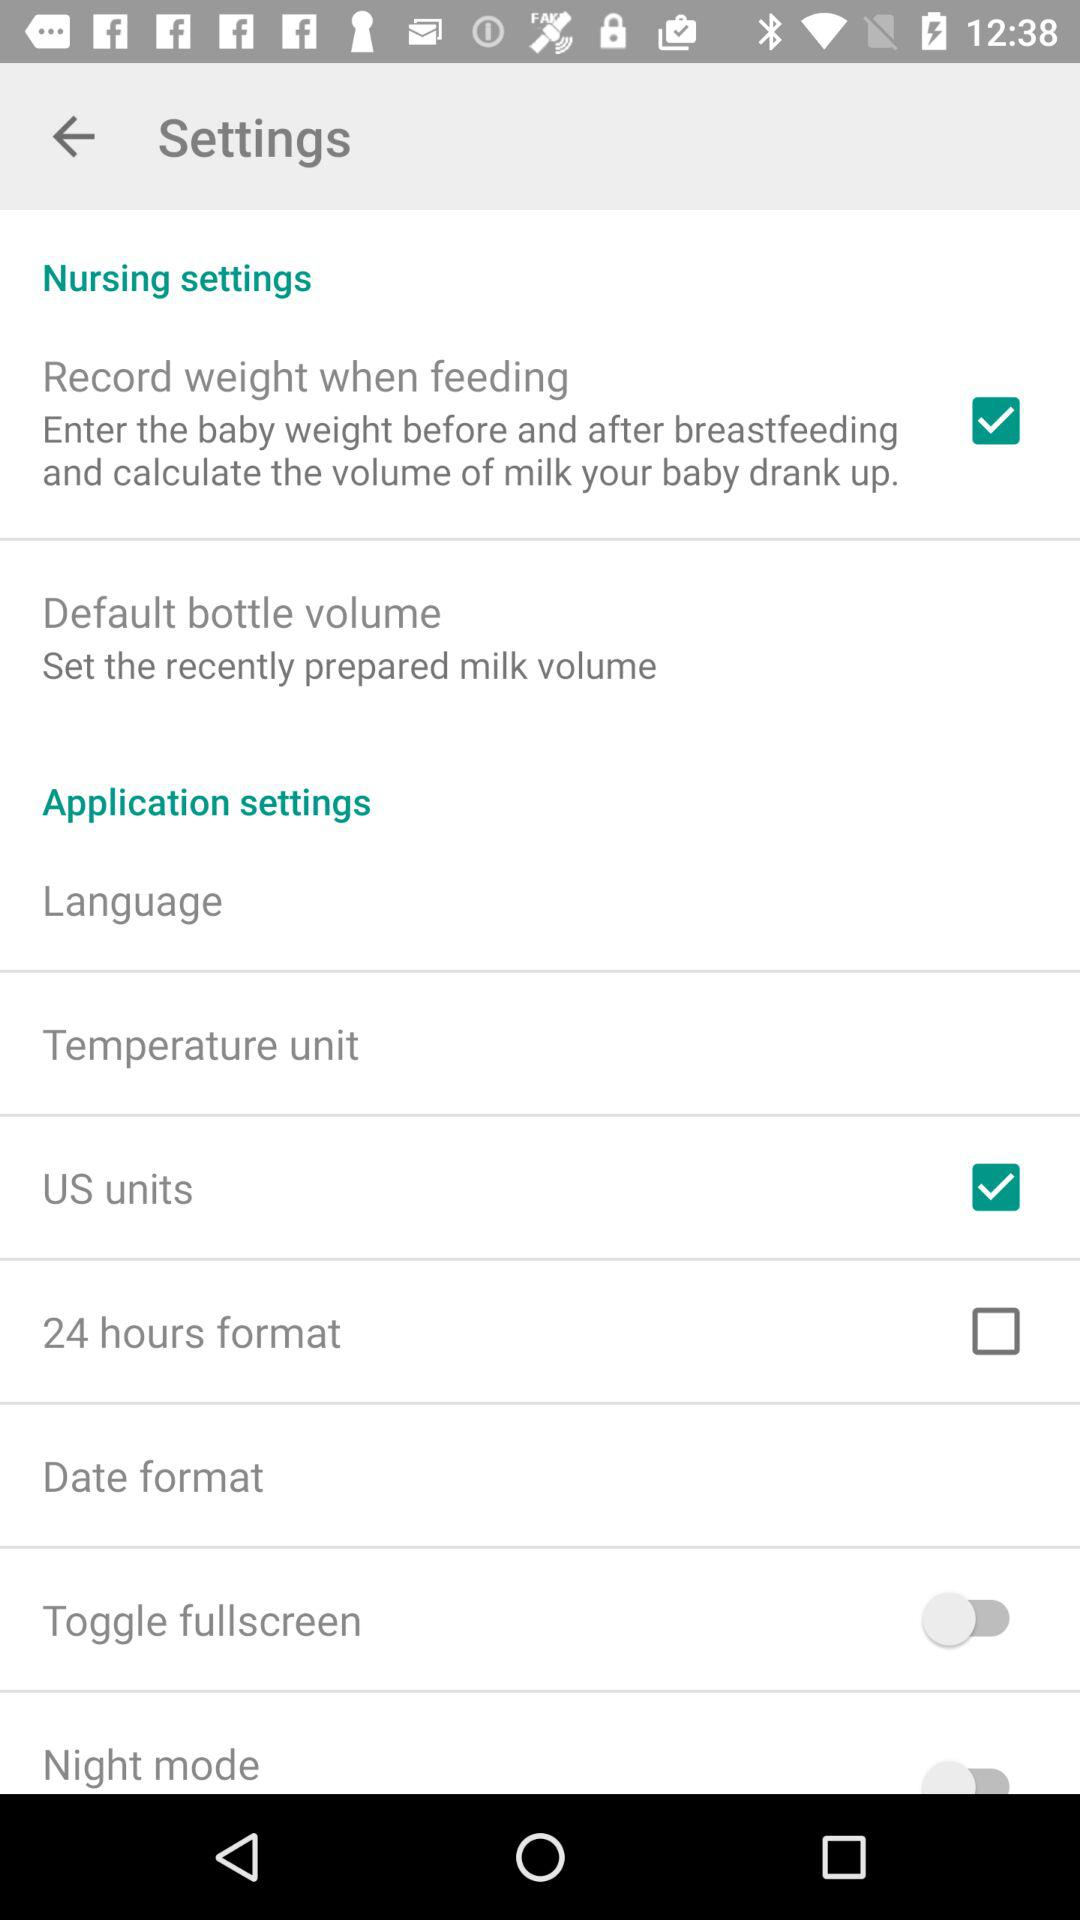What is the time format? The time format is 24 hours. 